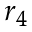Convert formula to latex. <formula><loc_0><loc_0><loc_500><loc_500>r _ { 4 }</formula> 